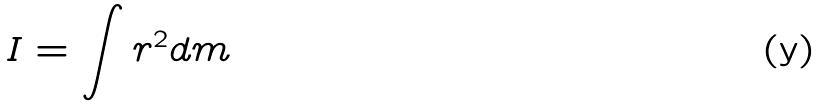<formula> <loc_0><loc_0><loc_500><loc_500>I = \int r ^ { 2 } d m</formula> 